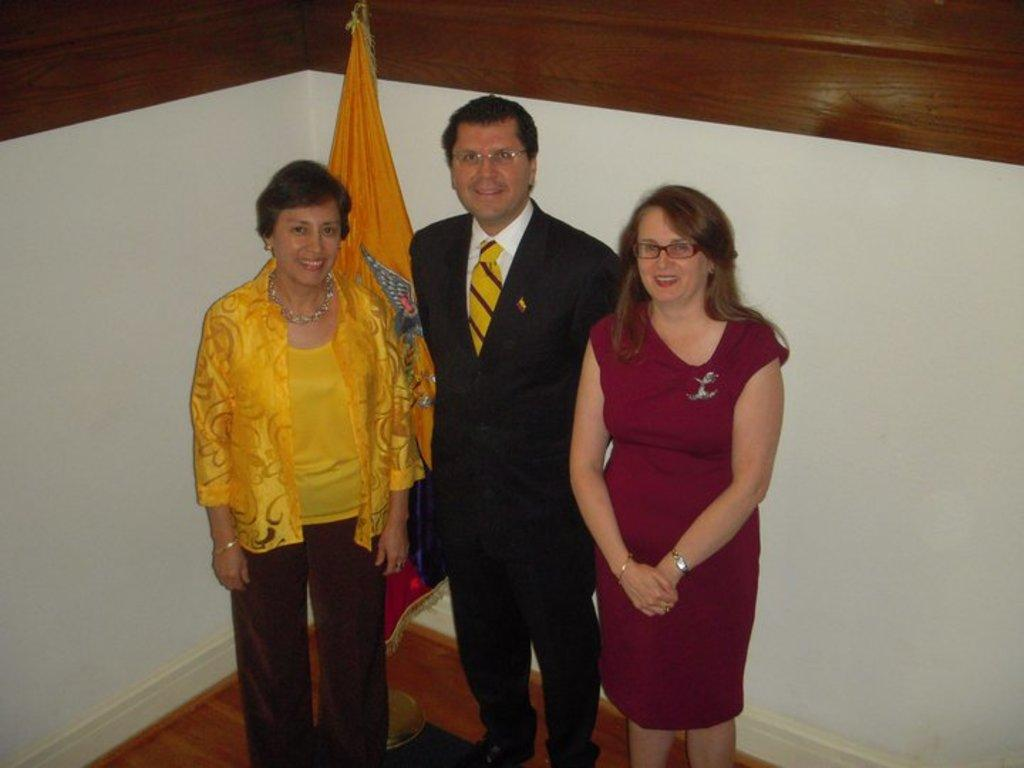How many people are present in the image? There are three people standing in the image. What is the facial expression of the people in the image? The people are smiling. What can be seen in the background of the image? There is a flag with a stand and a wall in the background of the image. What type of plant is growing in the jail cell in the image? There is no plant or jail cell present in the image. 